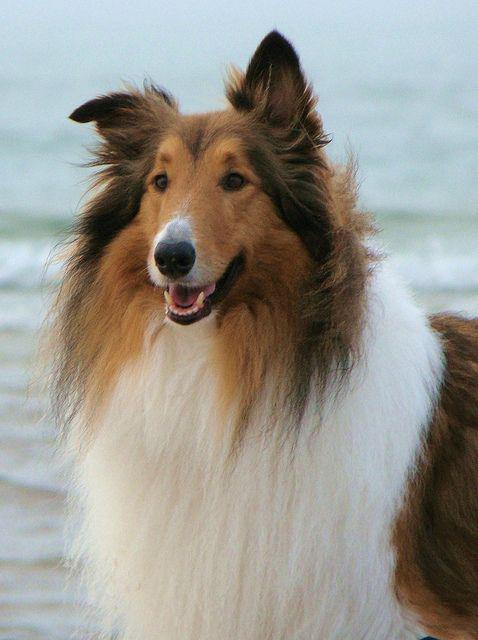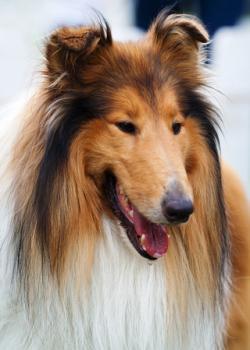The first image is the image on the left, the second image is the image on the right. Assess this claim about the two images: "A collie is pictured on an outdoor light blue background.". Correct or not? Answer yes or no. Yes. 